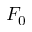Convert formula to latex. <formula><loc_0><loc_0><loc_500><loc_500>F _ { 0 }</formula> 